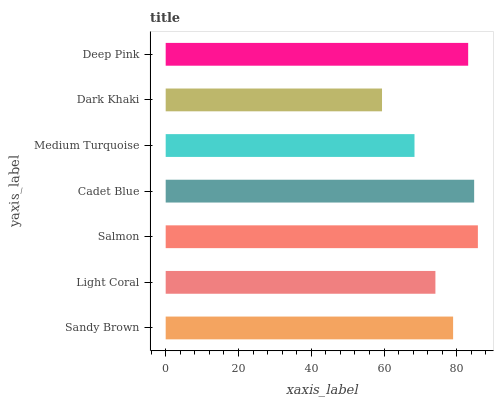Is Dark Khaki the minimum?
Answer yes or no. Yes. Is Salmon the maximum?
Answer yes or no. Yes. Is Light Coral the minimum?
Answer yes or no. No. Is Light Coral the maximum?
Answer yes or no. No. Is Sandy Brown greater than Light Coral?
Answer yes or no. Yes. Is Light Coral less than Sandy Brown?
Answer yes or no. Yes. Is Light Coral greater than Sandy Brown?
Answer yes or no. No. Is Sandy Brown less than Light Coral?
Answer yes or no. No. Is Sandy Brown the high median?
Answer yes or no. Yes. Is Sandy Brown the low median?
Answer yes or no. Yes. Is Light Coral the high median?
Answer yes or no. No. Is Medium Turquoise the low median?
Answer yes or no. No. 